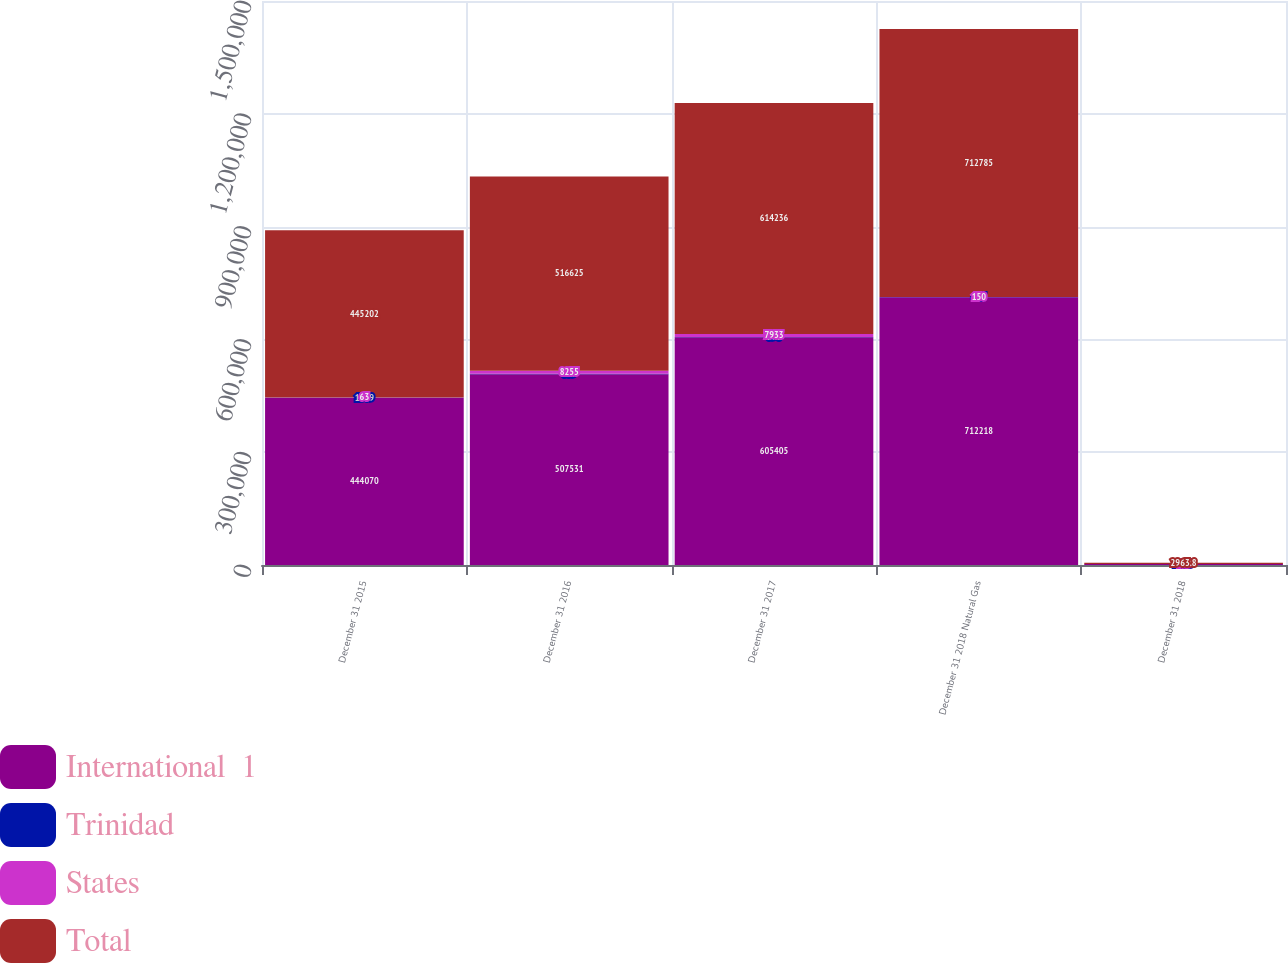<chart> <loc_0><loc_0><loc_500><loc_500><stacked_bar_chart><ecel><fcel>December 31 2015<fcel>December 31 2016<fcel>December 31 2017<fcel>December 31 2018 Natural Gas<fcel>December 31 2018<nl><fcel>International  1<fcel>444070<fcel>507531<fcel>605405<fcel>712218<fcel>2699<nl><fcel>Trinidad<fcel>1069<fcel>839<fcel>898<fcel>417<fcel>223.9<nl><fcel>States<fcel>63<fcel>8255<fcel>7933<fcel>150<fcel>40.9<nl><fcel>Total<fcel>445202<fcel>516625<fcel>614236<fcel>712785<fcel>2963.8<nl></chart> 